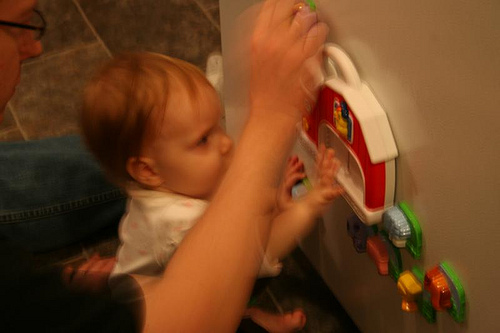<image>What holiday has the room featured in the picture been prepared for? I'm unsure about what holiday the room in the picture has been prepared for. It could be Christmas or a birthday. What holiday has the room featured in the picture been prepared for? I don't know what holiday the room featured in the picture has been prepared for. It can be Christmas or a birthday. 